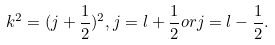<formula> <loc_0><loc_0><loc_500><loc_500>k ^ { 2 } = ( j + \frac { 1 } { 2 } ) ^ { 2 } , j = l + \frac { 1 } { 2 } o r j = l - \frac { 1 } { 2 } .</formula> 